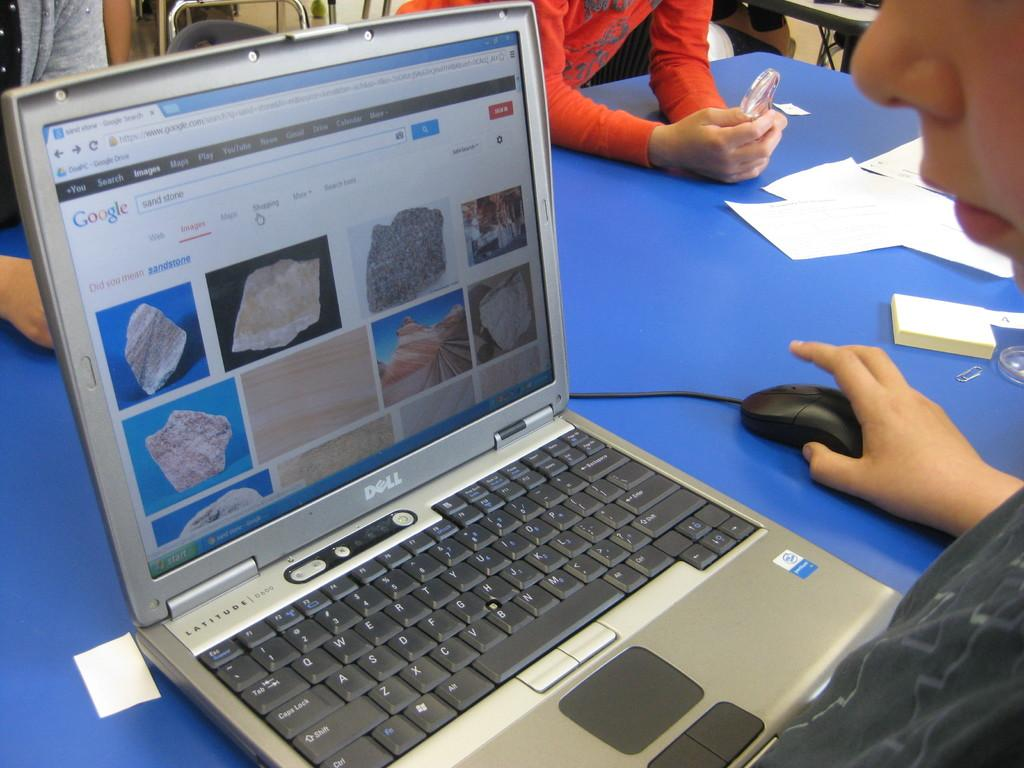<image>
Render a clear and concise summary of the photo. A Dell computer shows a Google search for sand stone. 